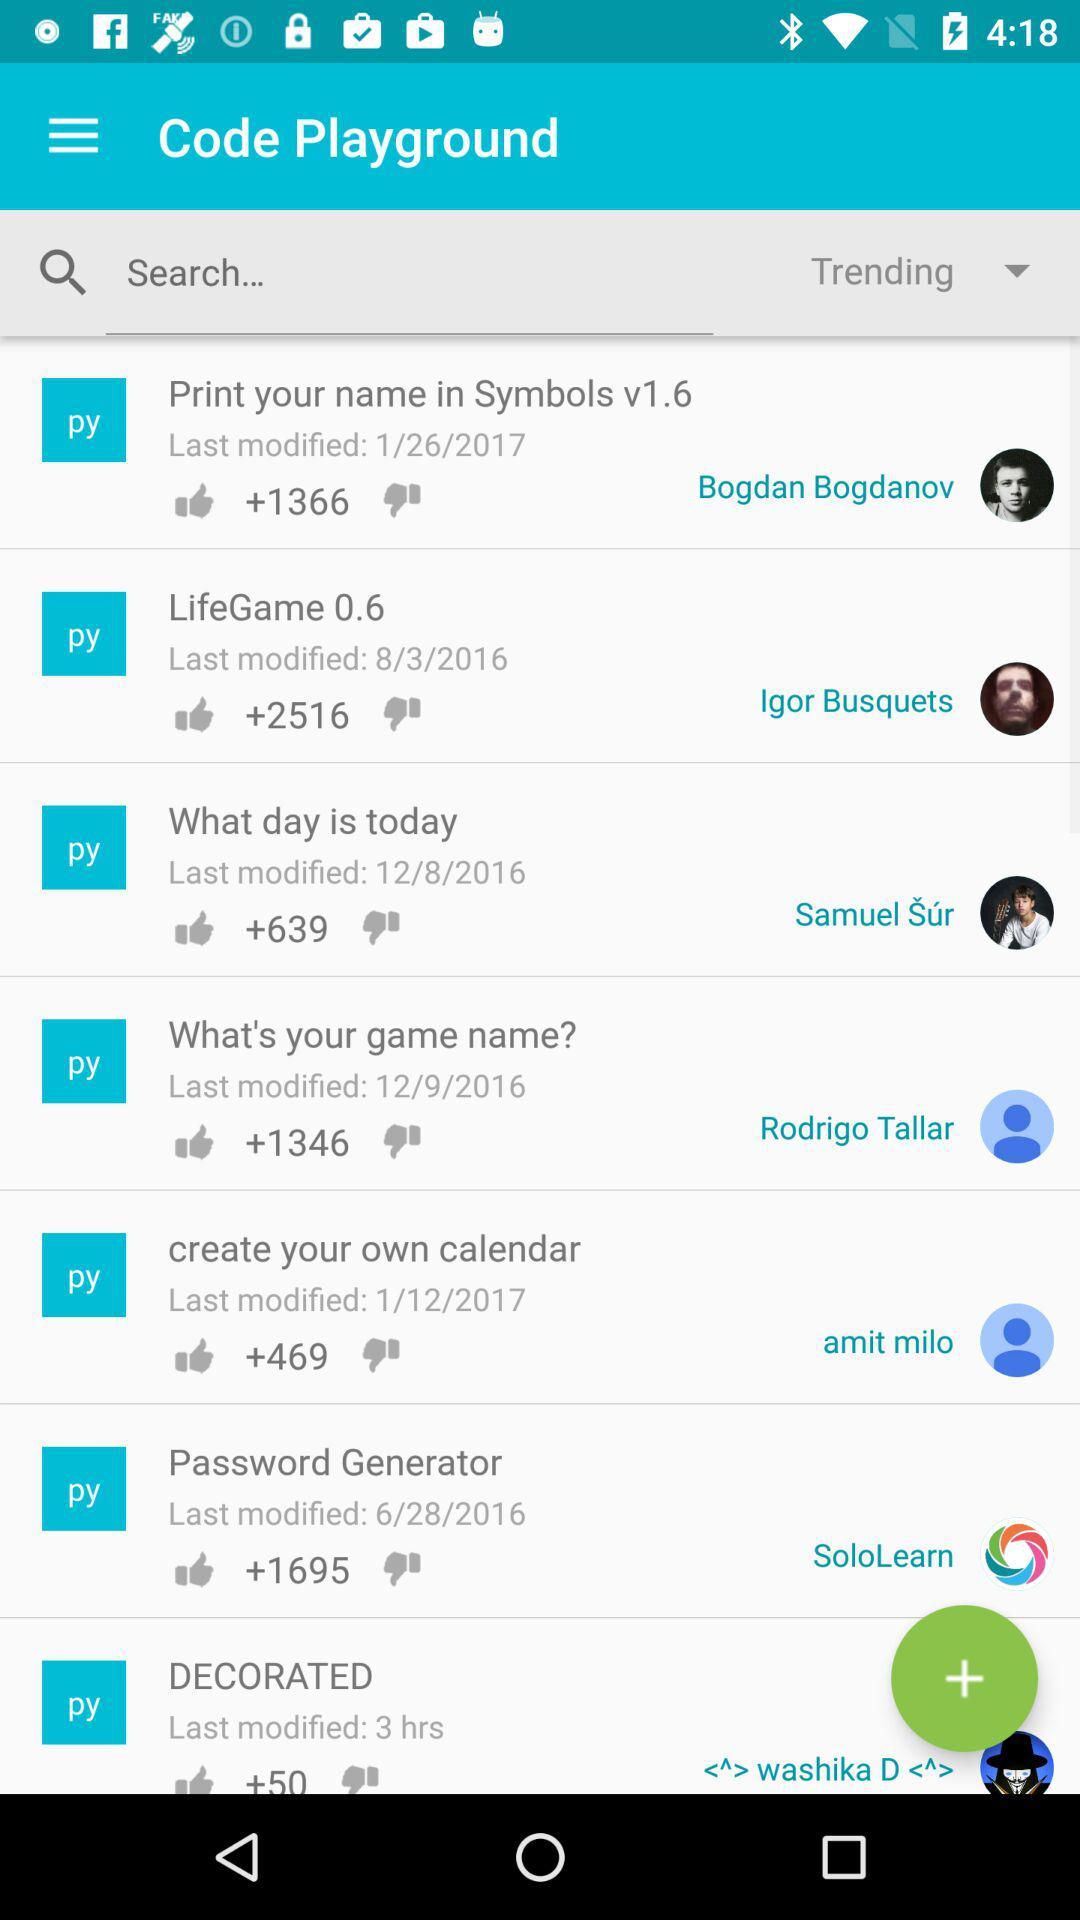How many thumbs up does the item with the most thumbs up have?
Answer the question using a single word or phrase. 2516 